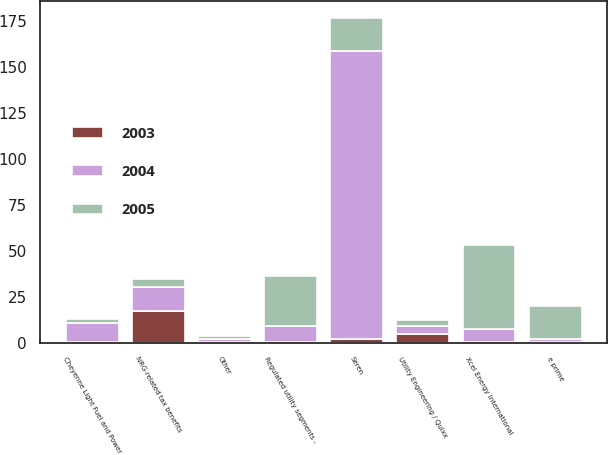Convert chart. <chart><loc_0><loc_0><loc_500><loc_500><stacked_bar_chart><ecel><fcel>Cheyenne Light Fuel and Power<fcel>Regulated utility segments -<fcel>NRG-related tax benefits<fcel>Xcel Energy International<fcel>e prime<fcel>Seren<fcel>Utility Engineering / Quixx<fcel>Other<nl><fcel>2003<fcel>0.2<fcel>0.2<fcel>17.2<fcel>0.1<fcel>0.1<fcel>1.8<fcel>4.4<fcel>0.2<nl><fcel>2004<fcel>10.3<fcel>9<fcel>12.8<fcel>7.3<fcel>1.8<fcel>156.6<fcel>4.7<fcel>1.9<nl><fcel>2005<fcel>2.5<fcel>26.8<fcel>4.4<fcel>45.5<fcel>17.8<fcel>18.3<fcel>3<fcel>1.6<nl></chart> 